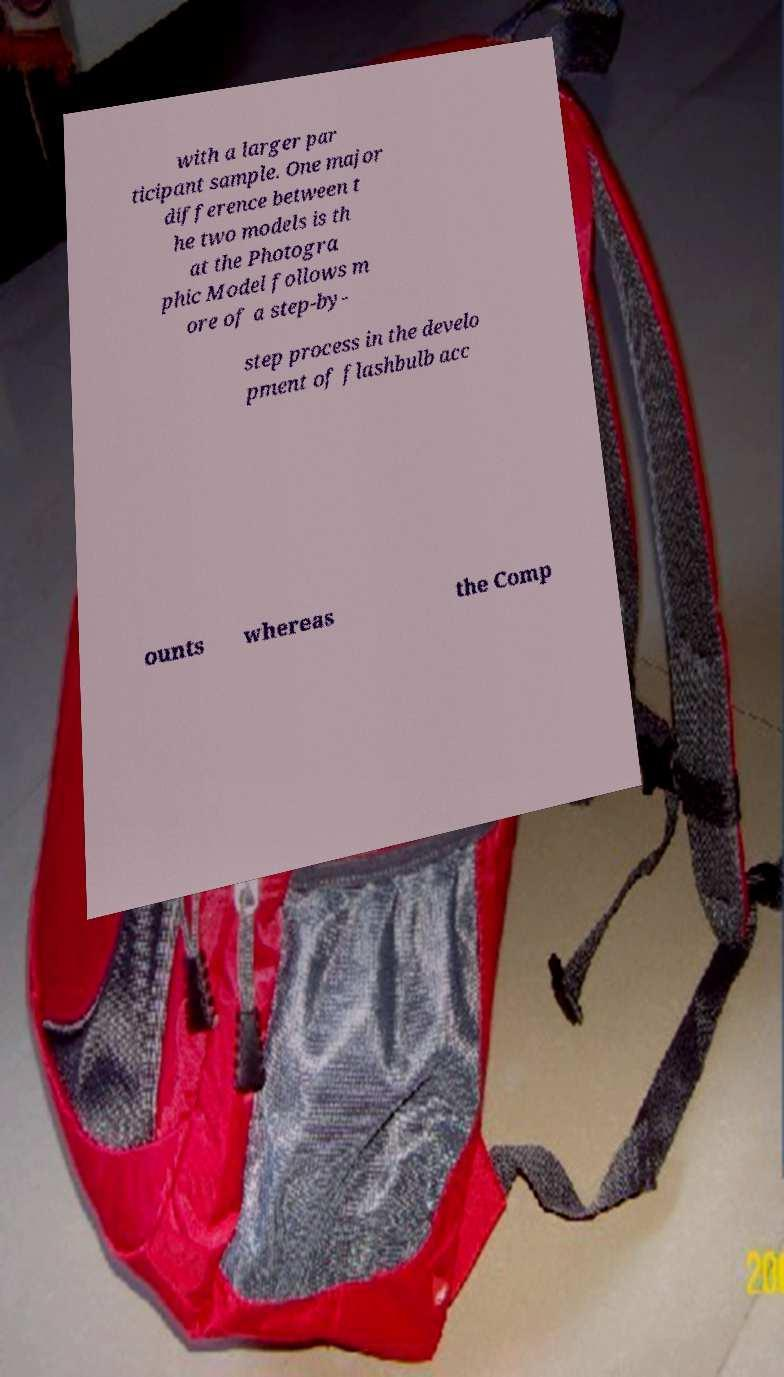For documentation purposes, I need the text within this image transcribed. Could you provide that? with a larger par ticipant sample. One major difference between t he two models is th at the Photogra phic Model follows m ore of a step-by- step process in the develo pment of flashbulb acc ounts whereas the Comp 